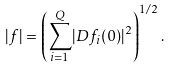Convert formula to latex. <formula><loc_0><loc_0><loc_500><loc_500>| f | = \left ( { \sum _ { i = 1 } ^ { Q } } | D f _ { i } ( 0 ) | ^ { 2 } \right ) ^ { 1 / 2 } .</formula> 